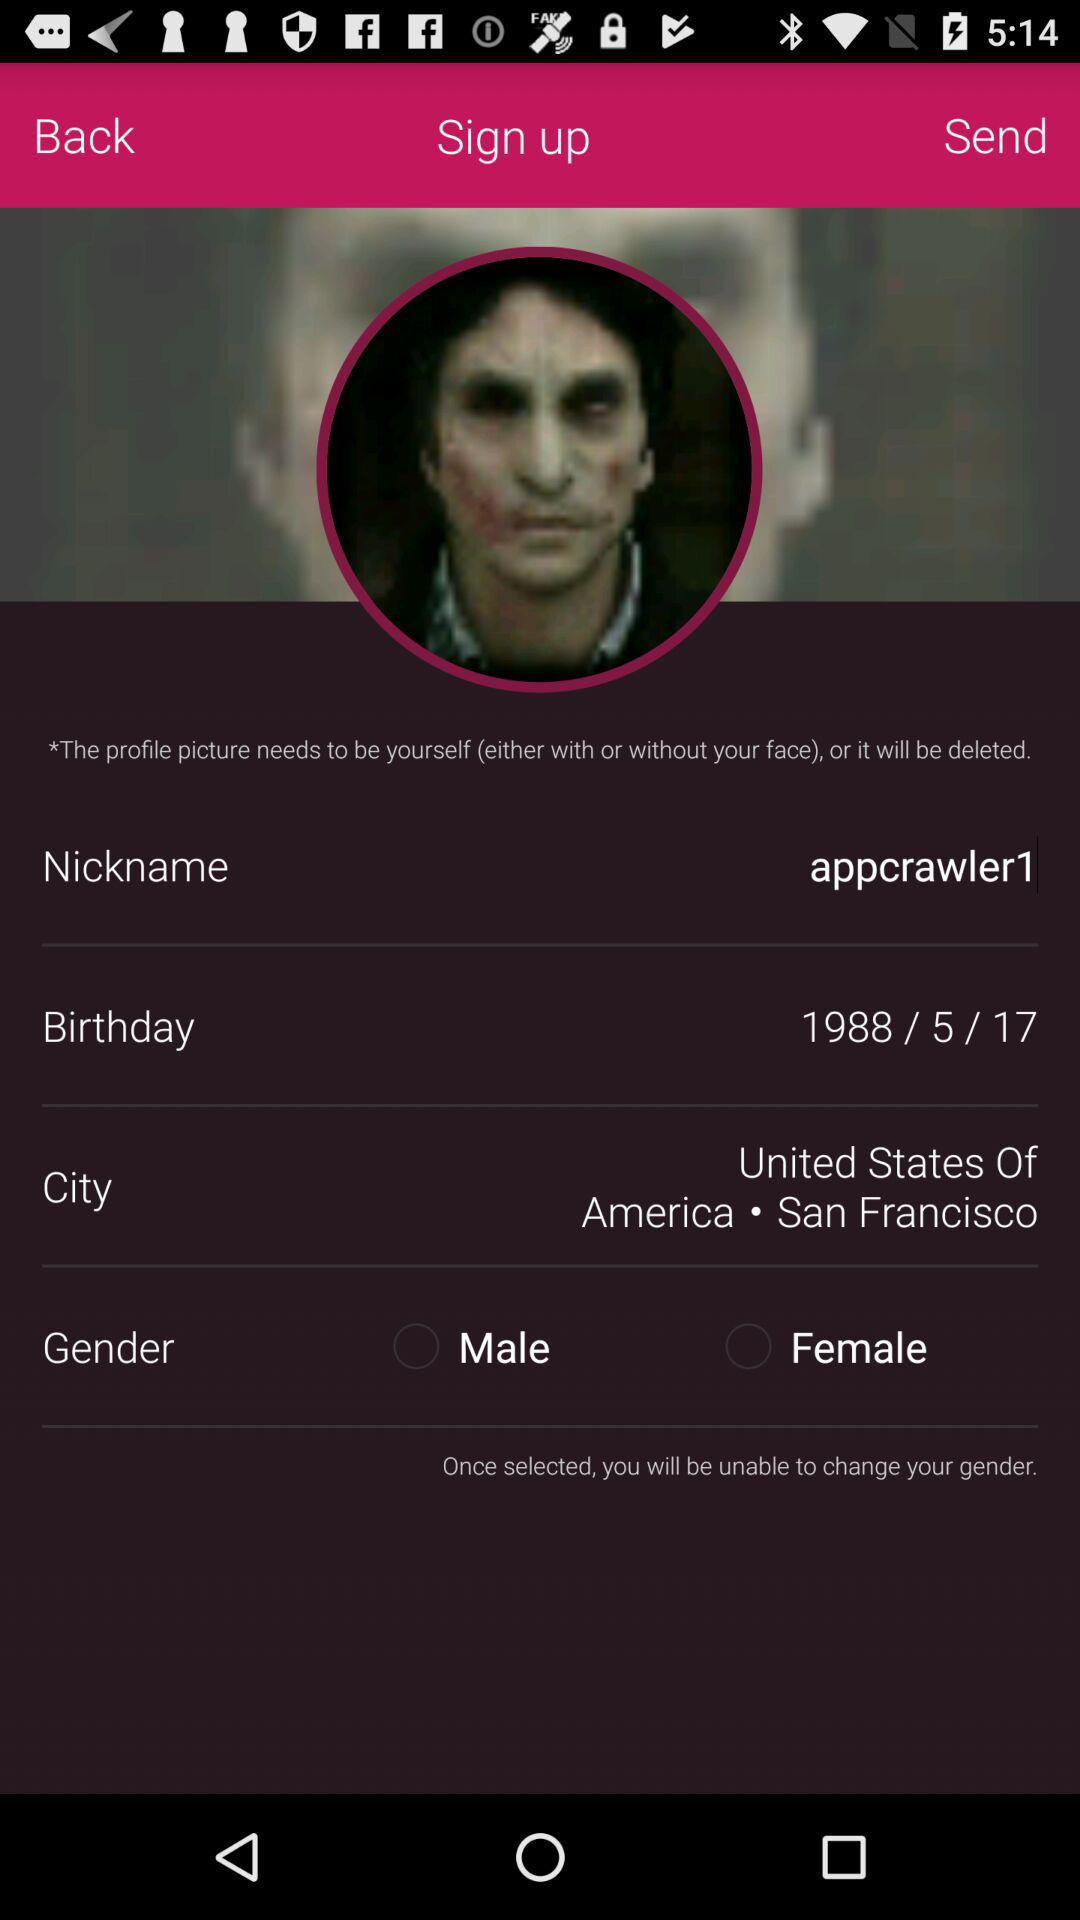What country is mentioned in the profile? The country is the "United States Of America". 